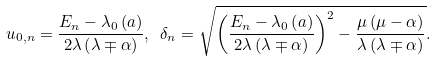Convert formula to latex. <formula><loc_0><loc_0><loc_500><loc_500>u _ { 0 , n } = \frac { E _ { n } - \lambda _ { 0 } \left ( a \right ) } { 2 \lambda \left ( \lambda \mp \alpha \right ) } , \ \delta _ { n } = \sqrt { \left ( \frac { E _ { n } - \lambda _ { 0 } \left ( a \right ) } { 2 \lambda \left ( \lambda \mp \alpha \right ) } \right ) ^ { 2 } - \frac { \mu \left ( \mu - \alpha \right ) } { \lambda \left ( \lambda \mp \alpha \right ) } } .</formula> 